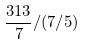<formula> <loc_0><loc_0><loc_500><loc_500>\frac { 3 1 3 } { 7 } / ( 7 / 5 )</formula> 